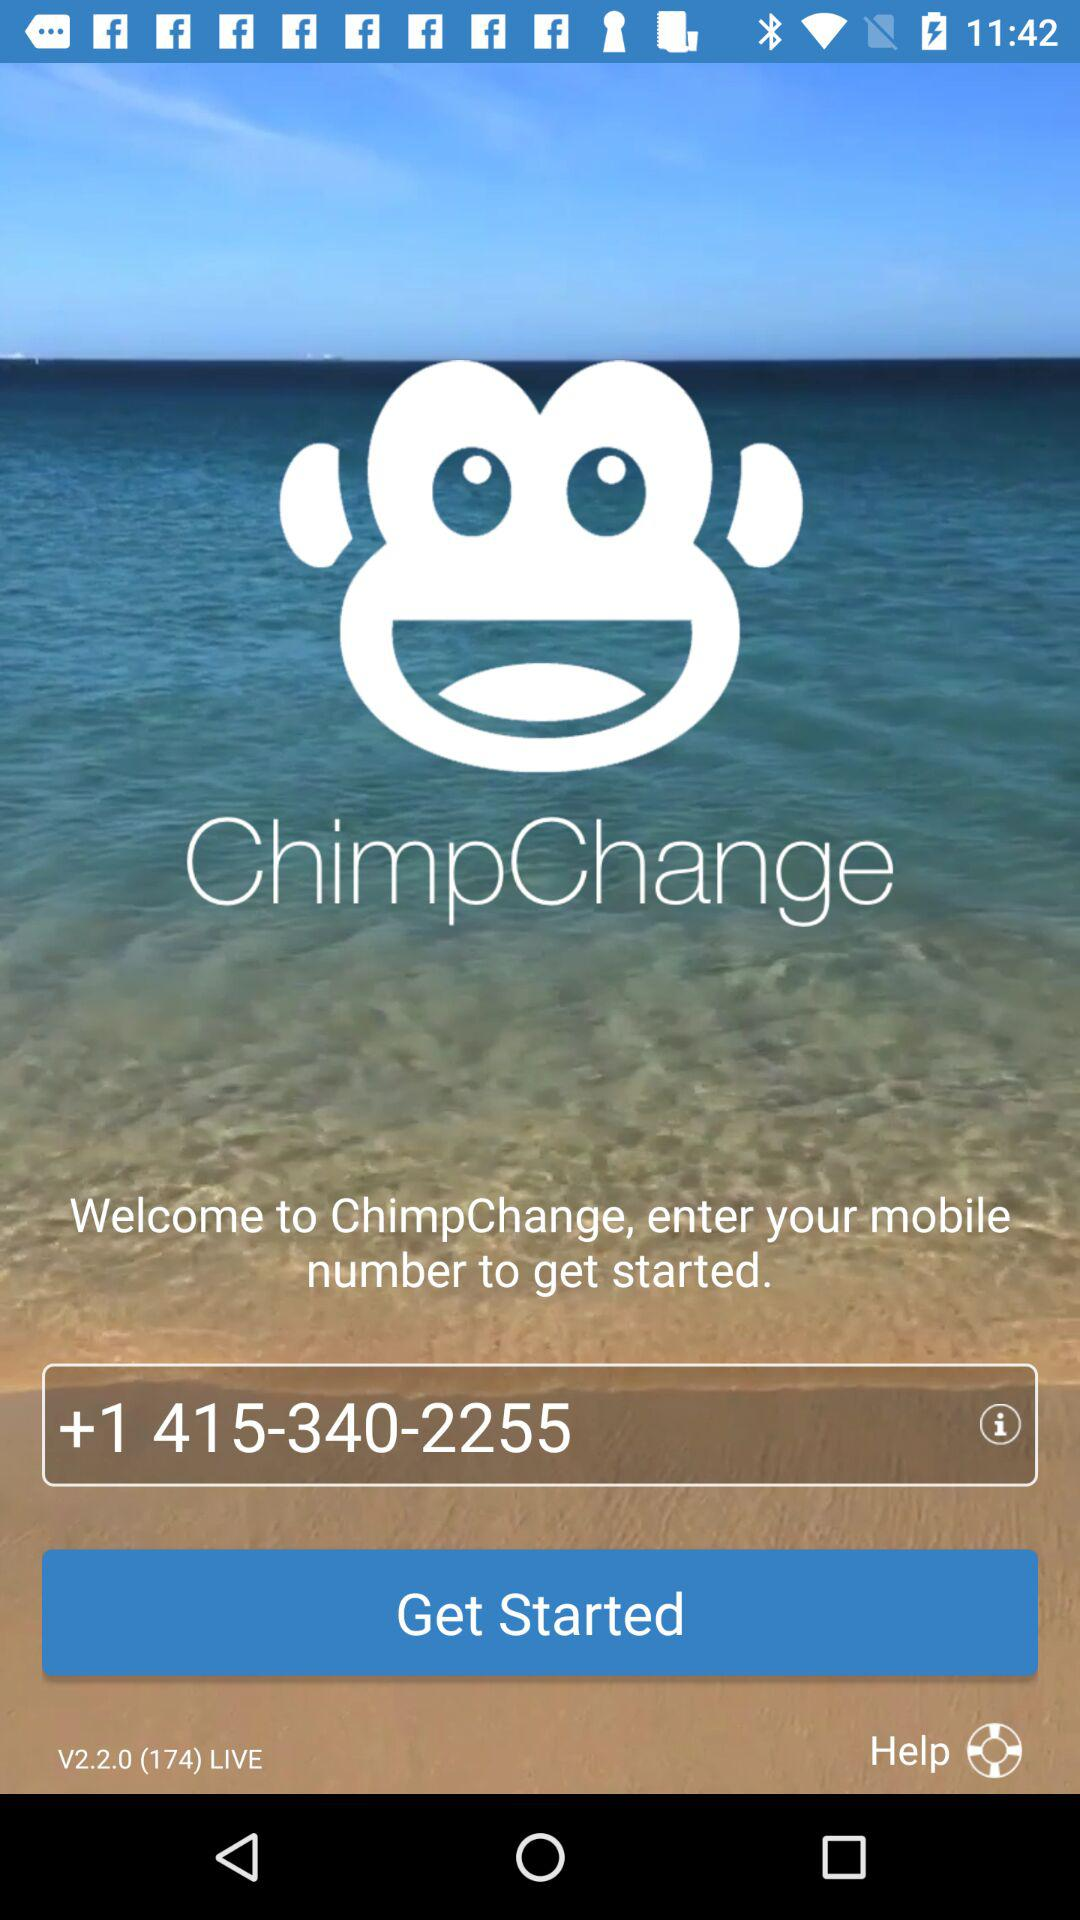What is the application name? The application name is "ChimpChange". 